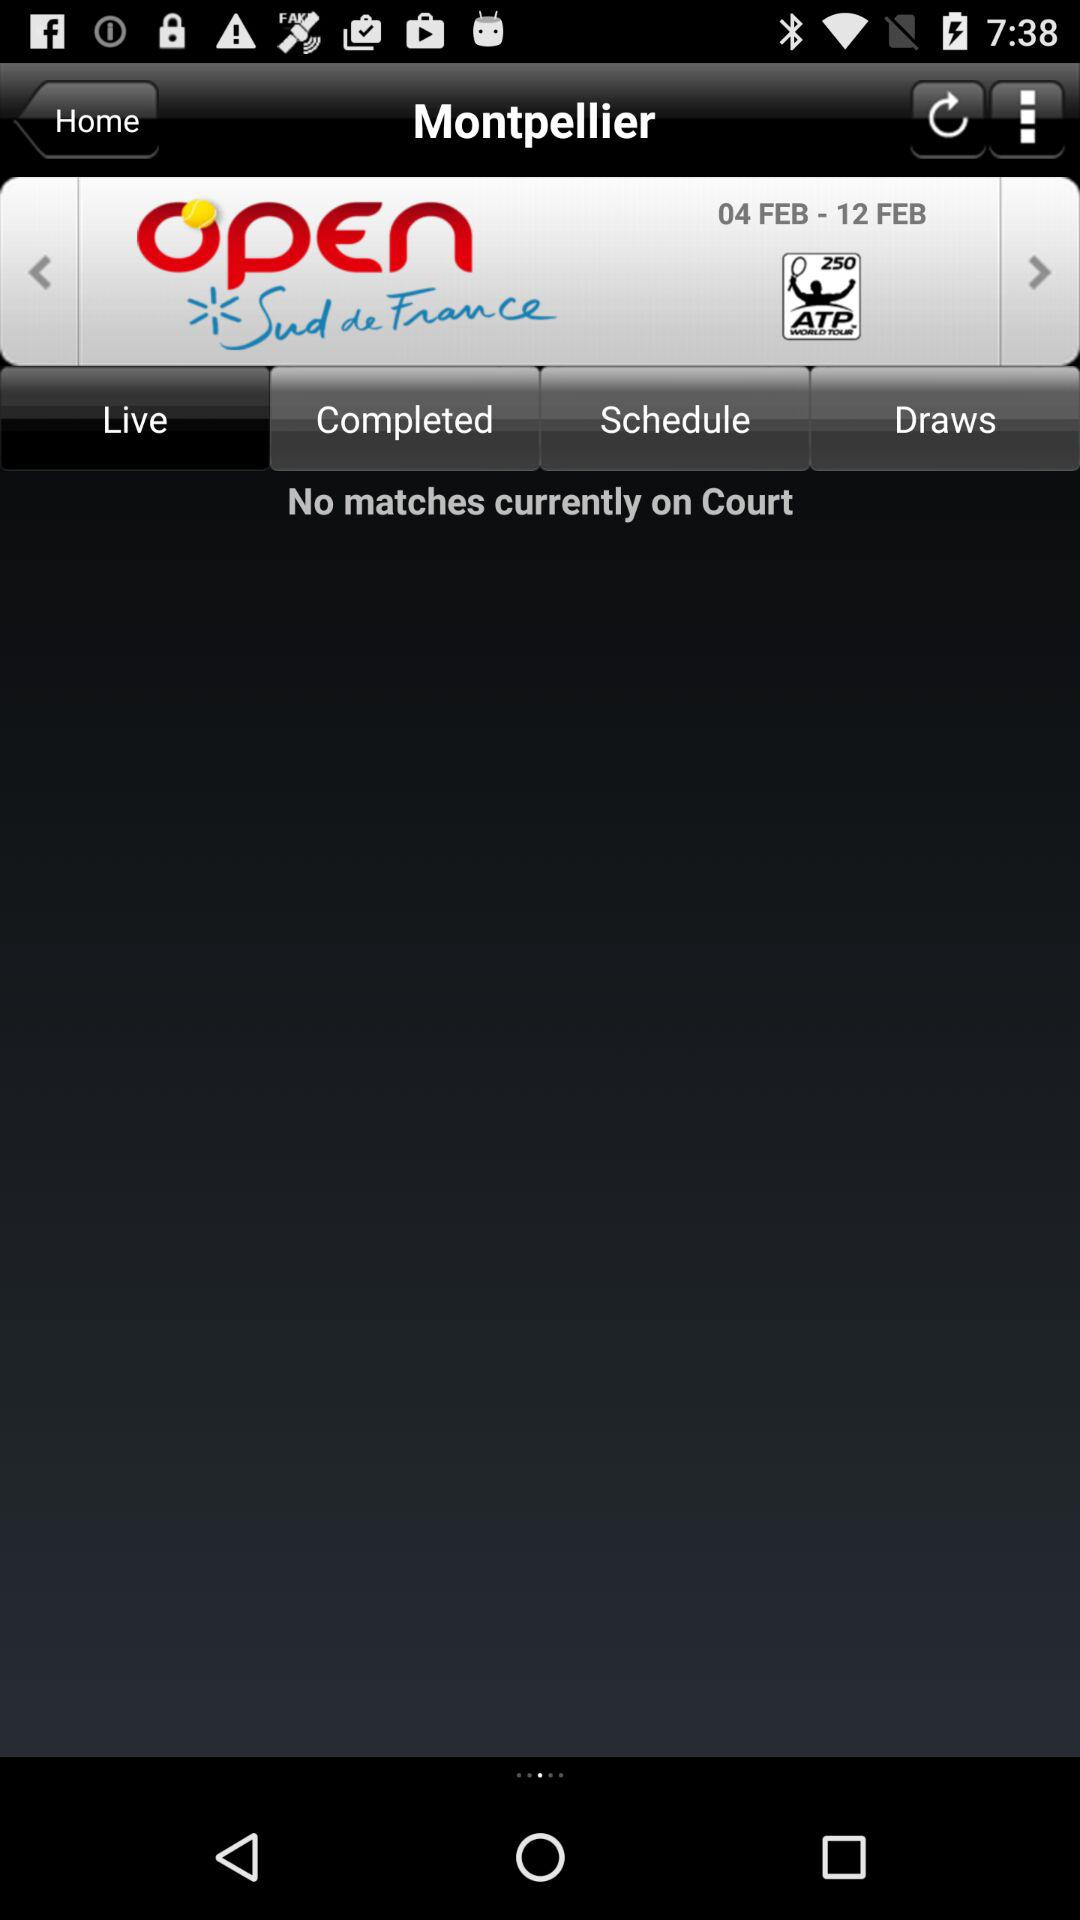How many matches are currently on the court? There are no matches currently on the court. 